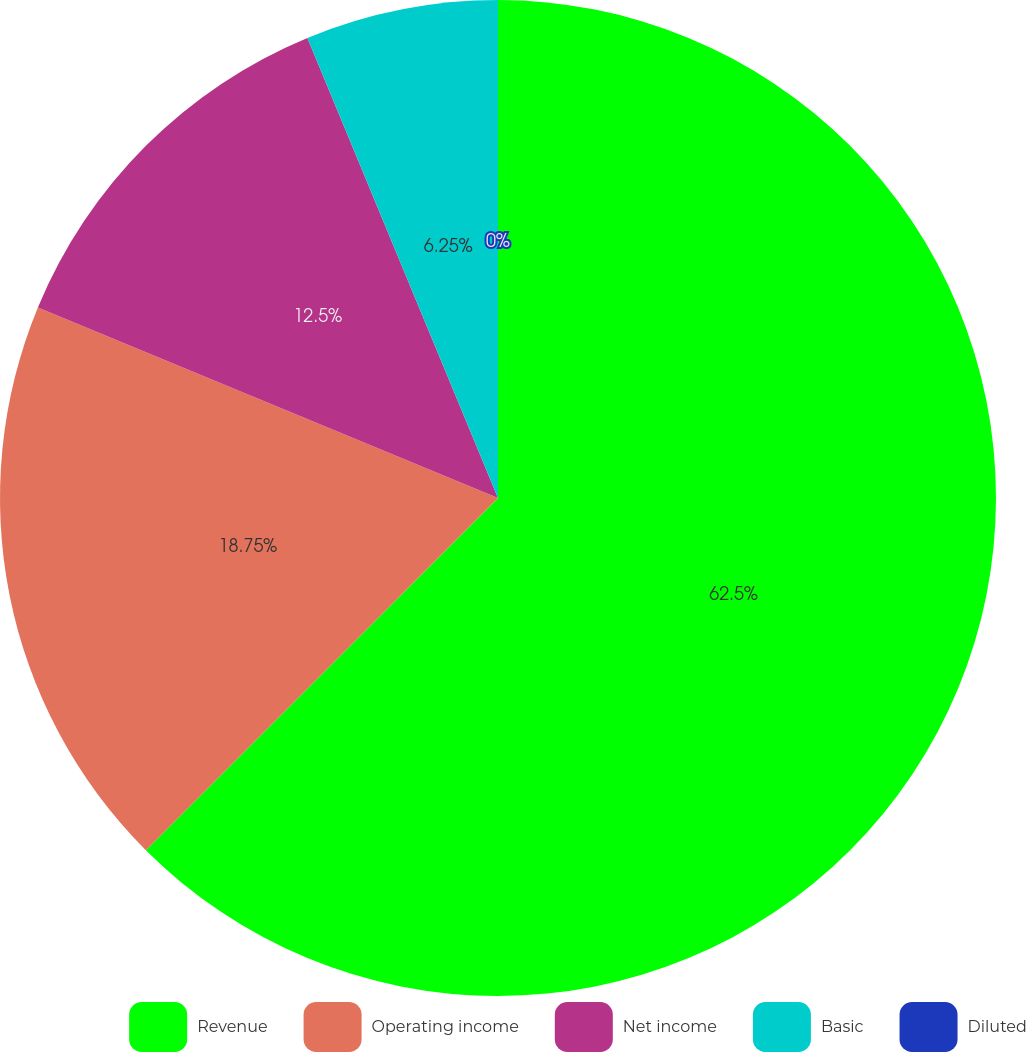Convert chart. <chart><loc_0><loc_0><loc_500><loc_500><pie_chart><fcel>Revenue<fcel>Operating income<fcel>Net income<fcel>Basic<fcel>Diluted<nl><fcel>62.5%<fcel>18.75%<fcel>12.5%<fcel>6.25%<fcel>0.0%<nl></chart> 